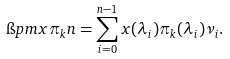<formula> <loc_0><loc_0><loc_500><loc_500>\i p m { x \pi _ { k } } { n } = \sum _ { i = 0 } ^ { n - 1 } x ( \lambda _ { i } ) \pi _ { k } ( \lambda _ { i } ) \nu _ { i } .</formula> 